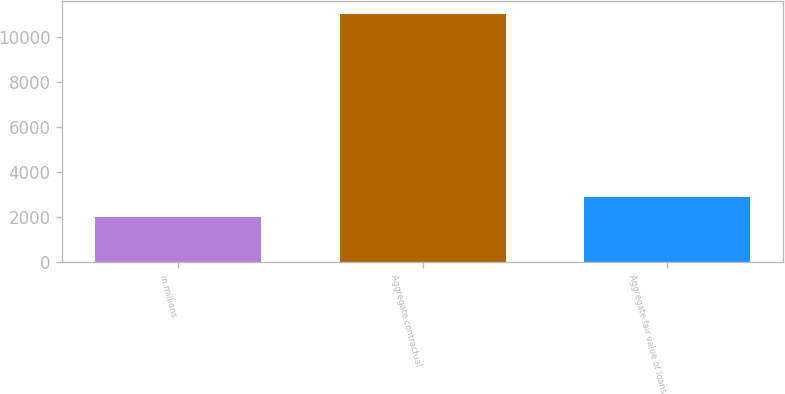<chart> <loc_0><loc_0><loc_500><loc_500><bar_chart><fcel>in millions<fcel>Aggregate contractual<fcel>Aggregate fair value of loans<nl><fcel>2013<fcel>11041<fcel>2915.8<nl></chart> 